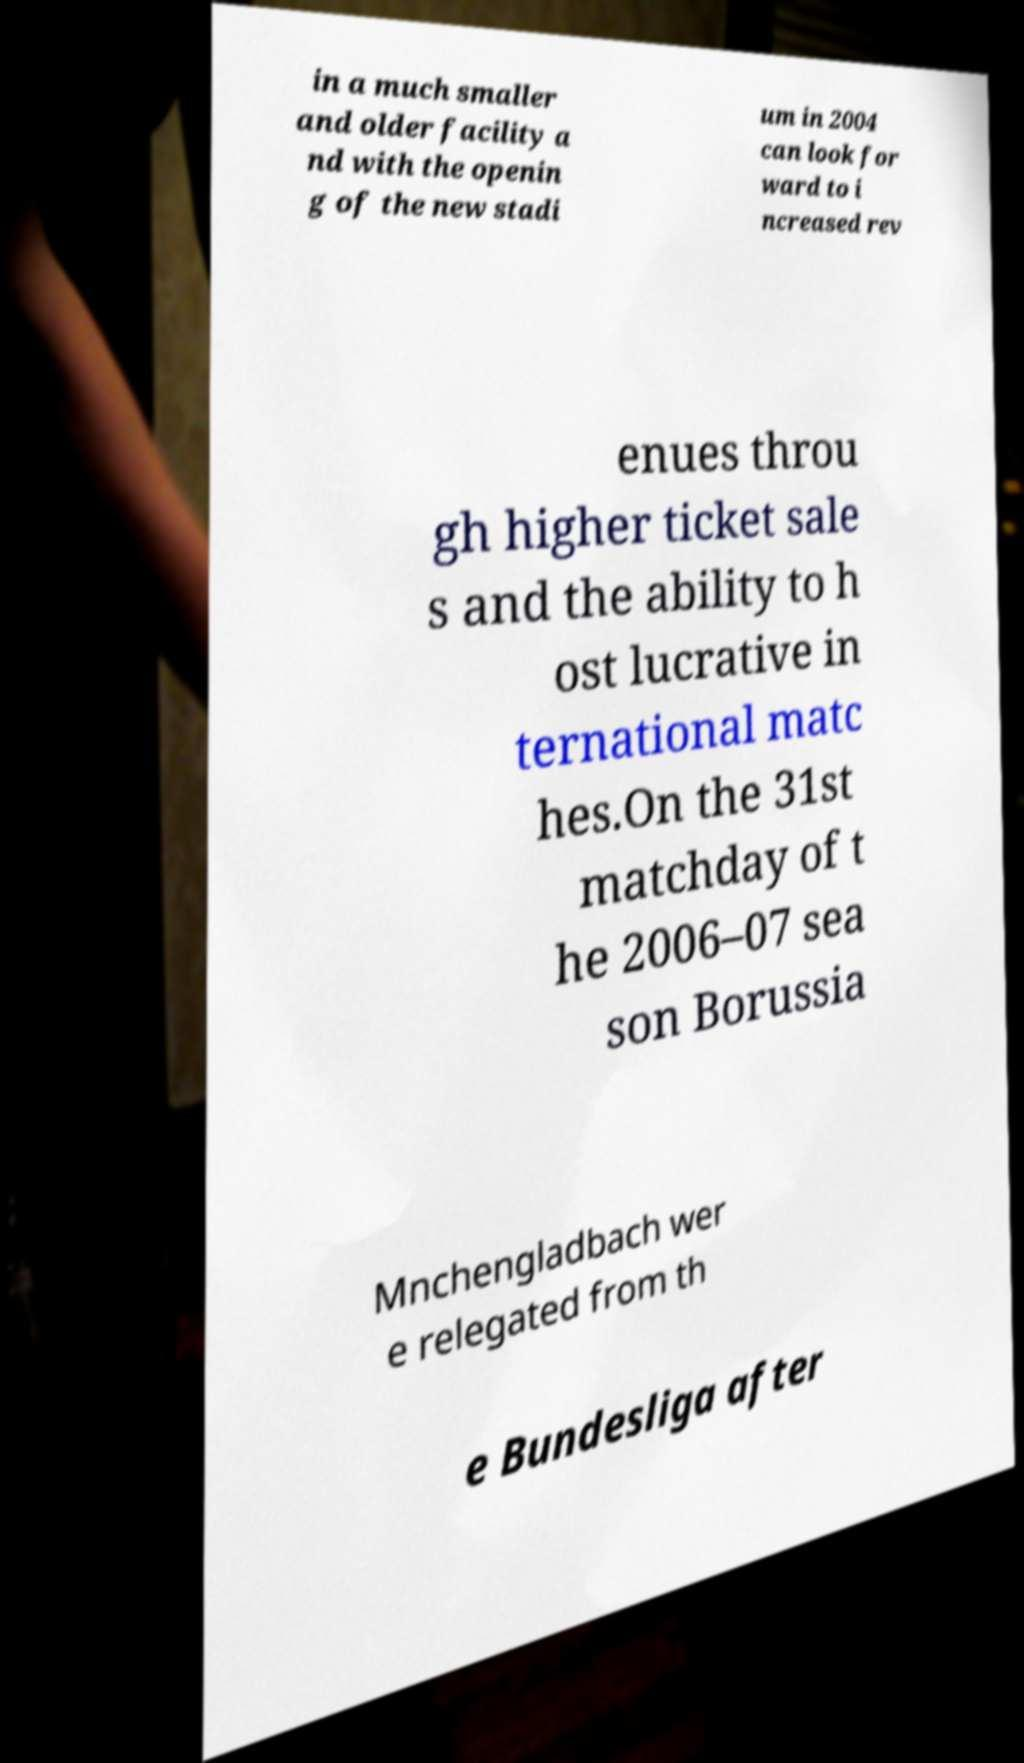Can you accurately transcribe the text from the provided image for me? in a much smaller and older facility a nd with the openin g of the new stadi um in 2004 can look for ward to i ncreased rev enues throu gh higher ticket sale s and the ability to h ost lucrative in ternational matc hes.On the 31st matchday of t he 2006–07 sea son Borussia Mnchengladbach wer e relegated from th e Bundesliga after 